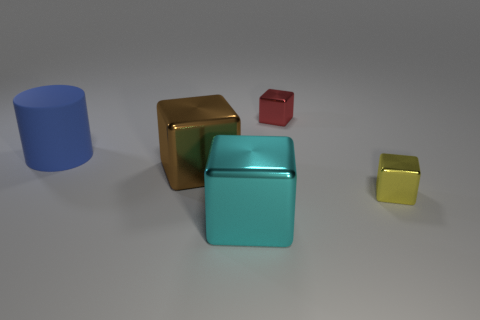What is the material of the big blue cylinder in front of the small metal cube that is behind the large metal block on the left side of the cyan shiny object?
Provide a short and direct response. Rubber. Do the small red thing and the large thing that is behind the brown cube have the same material?
Your answer should be very brief. No. What is the material of the small red thing that is the same shape as the cyan object?
Offer a terse response. Metal. Is there anything else that is the same material as the large blue cylinder?
Provide a short and direct response. No. Are there more large brown shiny things that are on the right side of the large blue cylinder than big brown shiny blocks behind the red object?
Offer a terse response. Yes. There is a large brown thing that is the same material as the yellow cube; what is its shape?
Your answer should be very brief. Cube. How many other objects are the same shape as the tiny yellow metal thing?
Ensure brevity in your answer.  3. There is a object behind the large matte cylinder; what is its shape?
Provide a succinct answer. Cube. The big cylinder is what color?
Keep it short and to the point. Blue. What number of other things are the same size as the yellow metal block?
Your answer should be very brief. 1. 